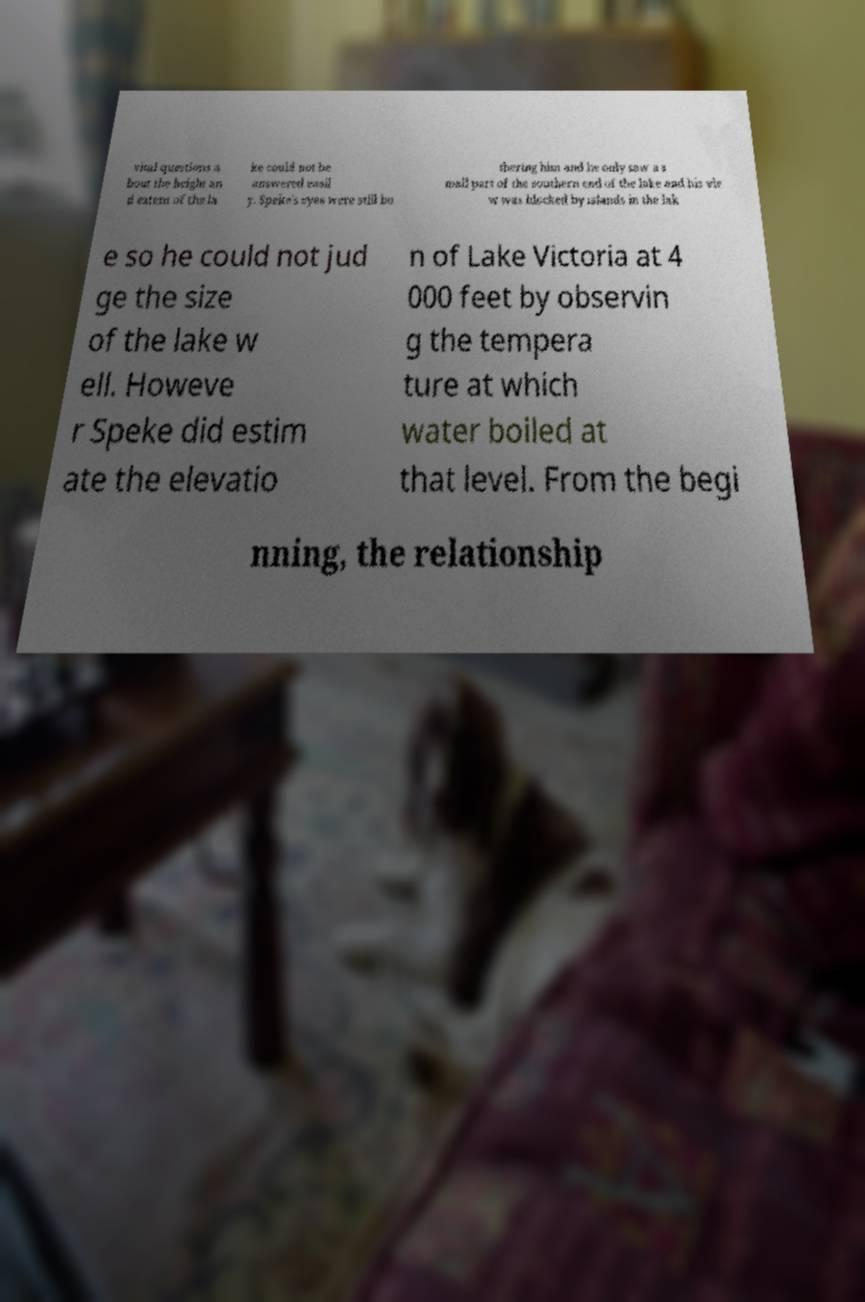I need the written content from this picture converted into text. Can you do that? vital questions a bout the height an d extent of the la ke could not be answered easil y. Speke's eyes were still bo thering him and he only saw a s mall part of the southern end of the lake and his vie w was blocked by islands in the lak e so he could not jud ge the size of the lake w ell. Howeve r Speke did estim ate the elevatio n of Lake Victoria at 4 000 feet by observin g the tempera ture at which water boiled at that level. From the begi nning, the relationship 